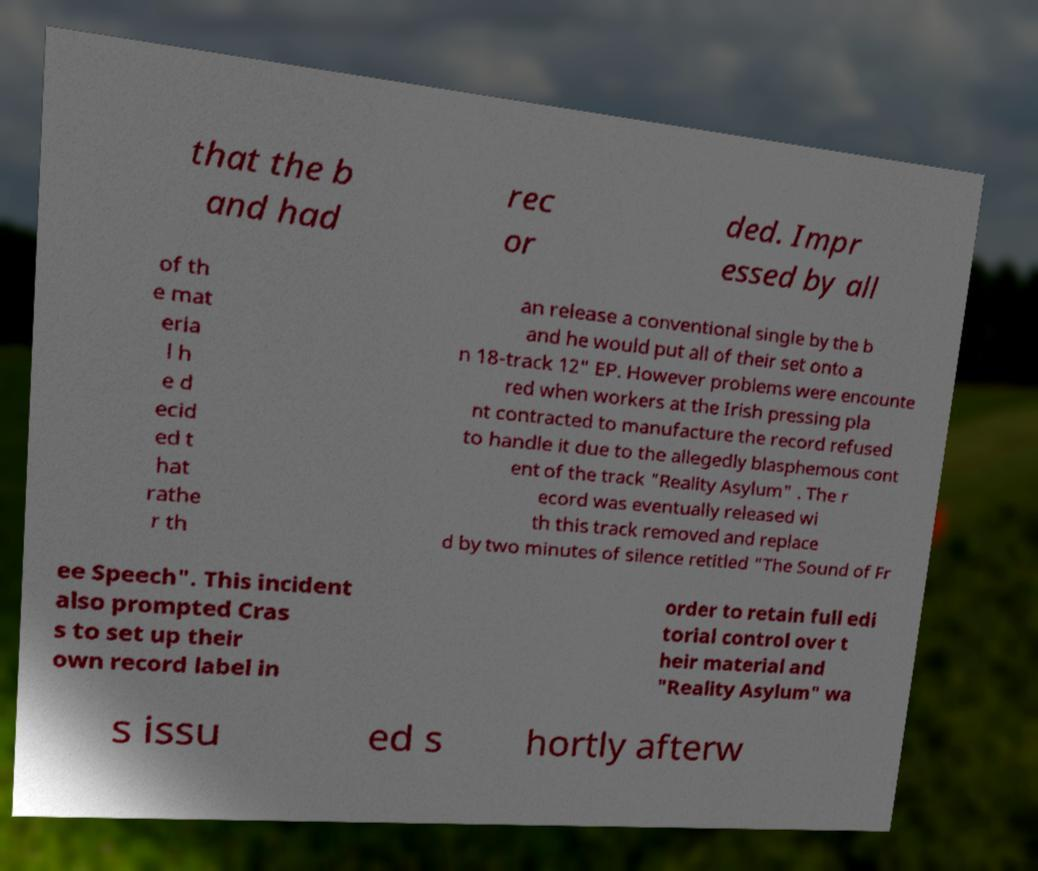There's text embedded in this image that I need extracted. Can you transcribe it verbatim? that the b and had rec or ded. Impr essed by all of th e mat eria l h e d ecid ed t hat rathe r th an release a conventional single by the b and he would put all of their set onto a n 18-track 12" EP. However problems were encounte red when workers at the Irish pressing pla nt contracted to manufacture the record refused to handle it due to the allegedly blasphemous cont ent of the track "Reality Asylum" . The r ecord was eventually released wi th this track removed and replace d by two minutes of silence retitled "The Sound of Fr ee Speech". This incident also prompted Cras s to set up their own record label in order to retain full edi torial control over t heir material and "Reality Asylum" wa s issu ed s hortly afterw 